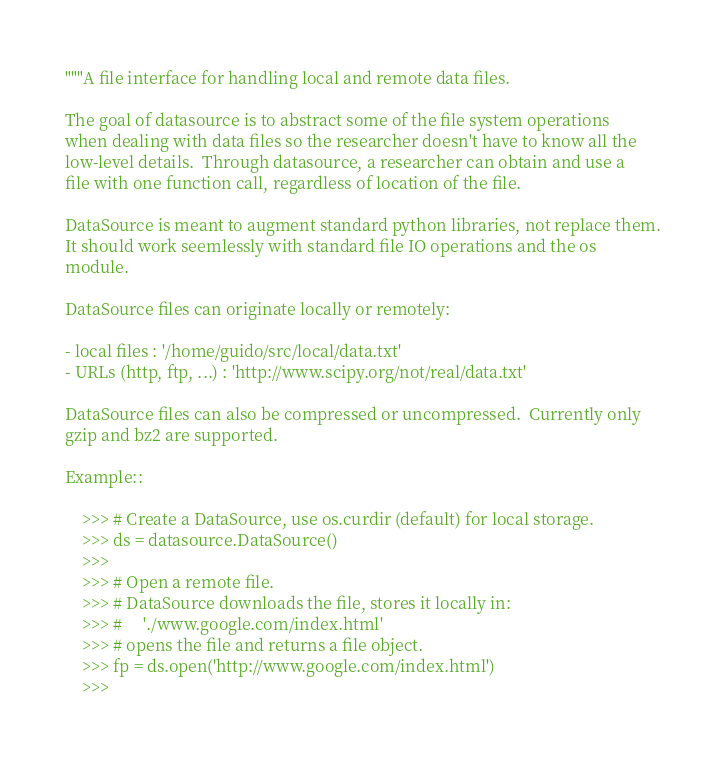<code> <loc_0><loc_0><loc_500><loc_500><_Python_>"""A file interface for handling local and remote data files.

The goal of datasource is to abstract some of the file system operations
when dealing with data files so the researcher doesn't have to know all the
low-level details.  Through datasource, a researcher can obtain and use a
file with one function call, regardless of location of the file.

DataSource is meant to augment standard python libraries, not replace them.
It should work seemlessly with standard file IO operations and the os
module.

DataSource files can originate locally or remotely:

- local files : '/home/guido/src/local/data.txt'
- URLs (http, ftp, ...) : 'http://www.scipy.org/not/real/data.txt'

DataSource files can also be compressed or uncompressed.  Currently only
gzip and bz2 are supported.

Example::

    >>> # Create a DataSource, use os.curdir (default) for local storage.
    >>> ds = datasource.DataSource()
    >>>
    >>> # Open a remote file.
    >>> # DataSource downloads the file, stores it locally in:
    >>> #     './www.google.com/index.html'
    >>> # opens the file and returns a file object.
    >>> fp = ds.open('http://www.google.com/index.html')
    >>></code> 